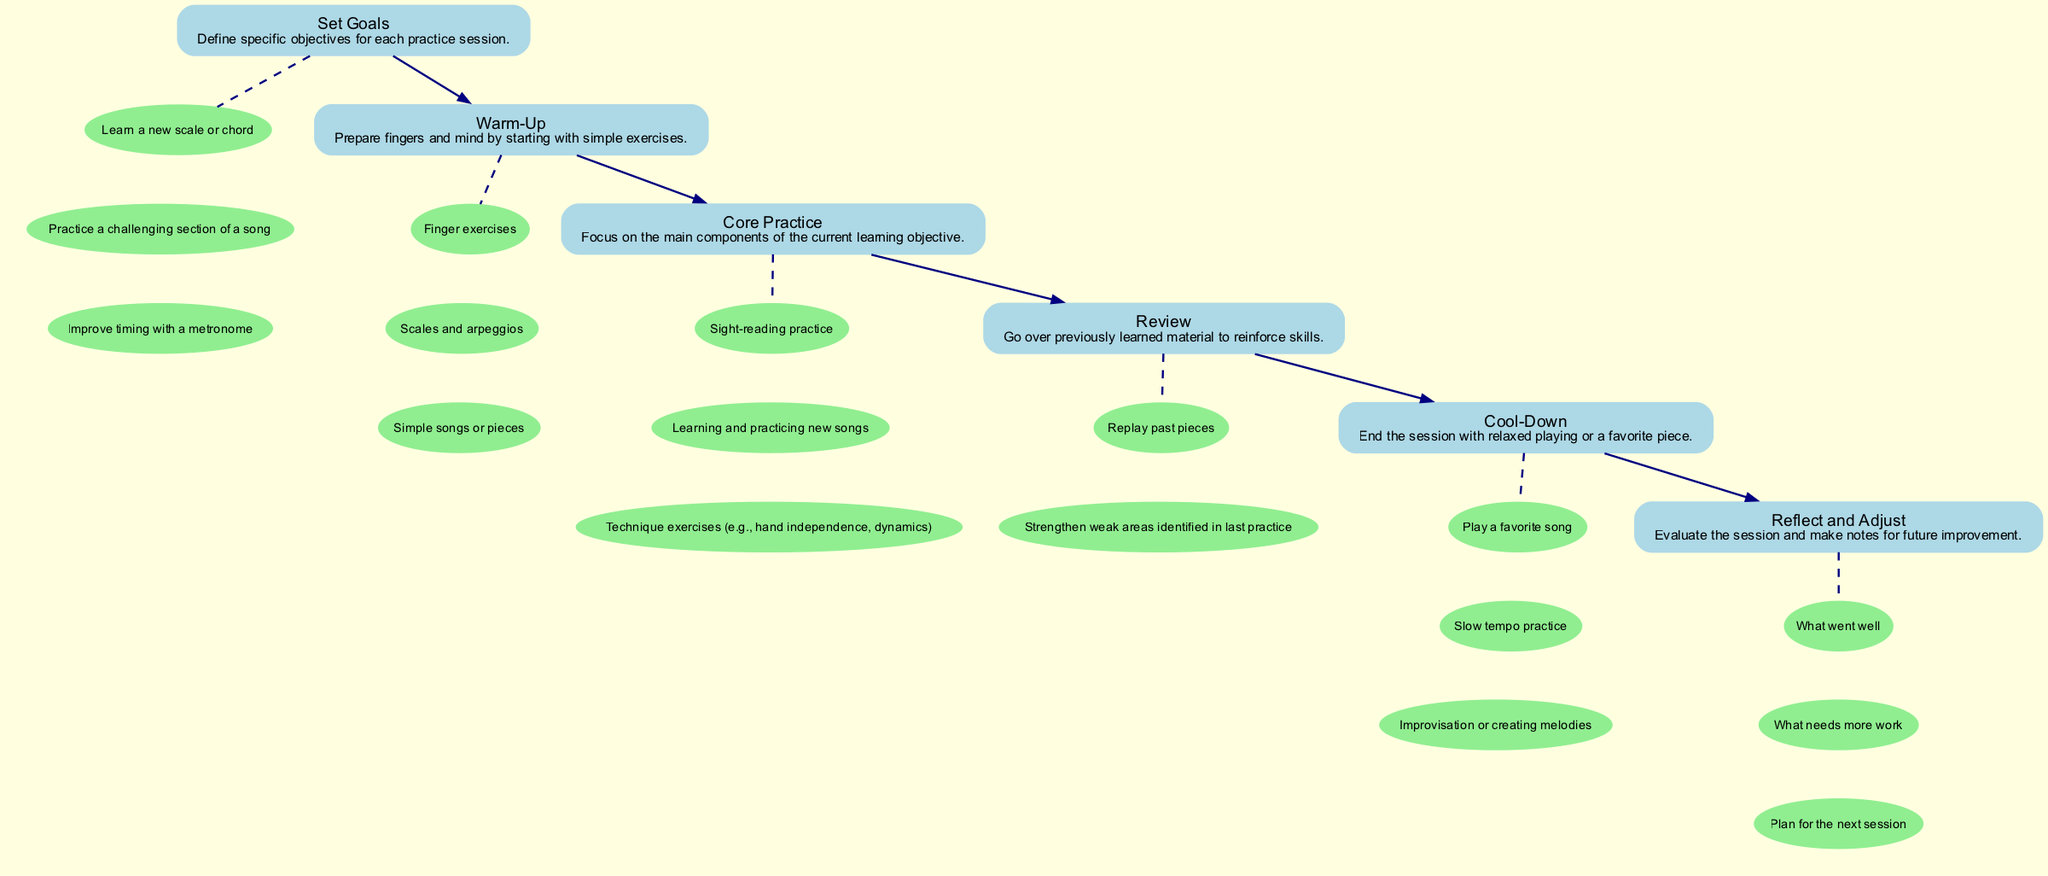What is the first step in the piano practice flow chart? The first step shown in the diagram is "Set Goals," where specific objectives for each practice session are defined. This is evident as it is the initial node before any other nodes.
Answer: Set Goals How many nodes are in the practice flow chart? By counting each of the distinct elements in the diagram, there are a total of six nodes representing different stages of the practice process.
Answer: Six What is the last step of the practice session? The last step in the flow chart is "Reflect and Adjust," which involves evaluating the session and making notes for future improvement. This is the final node in the sequence of practice activities.
Answer: Reflect and Adjust Name one detail under "Warm-Up." One detail listed under the "Warm-Up" step is "Finger exercises," as it is one of the activities recommended to prepare fingers and mind. This detail is easily identifiable as part of the subgraph related to the "Warm-Up" node.
Answer: Finger exercises What is the relationship between "Core Practice" and "Review"? The relationship is sequential; "Core Practice" is followed by "Review" in the flow chart, signifying that after focusing on core components, the next step involves going over previously learned material. This can be traced by the directed edge connecting these two nodes in the diagram.
Answer: Sequential Which step involves playing a favorite song? The step that involves playing a favorite song is "Cool-Down," where the session ends with relaxed playing or a choice of enjoyable music. This is directly mentioned in the details of that specific node.
Answer: Cool-Down What are the first two details listed under "Set Goals"? The first two details listed under "Set Goals" are "Learn a new scale or chord" and "Practice a challenging section of a song." These details are among the specific objectives outlined for the practice session.
Answer: Learn a new scale or chord, Practice a challenging section of a song How does "Reflect and Adjust" connect to previous steps? "Reflect and Adjust" connects to previous steps by evaluating what went well and what needs more work after completing all prior activities in the flow. This is observed as the last node where feedback from the entire practice session is synthesized and used to shape future sessions.
Answer: Evaluates previous steps What does "Core Practice" focus on? "Core Practice" focuses on the main components of the current learning objective, such as sight-reading practice, new songs, and technique exercises, as explicitly described in its overview.
Answer: Main components of the current learning objective 